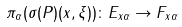Convert formula to latex. <formula><loc_0><loc_0><loc_500><loc_500>\pi _ { \alpha } ( \sigma ( P ) ( x , \xi ) ) \colon E _ { x \alpha } \to F _ { x \alpha }</formula> 